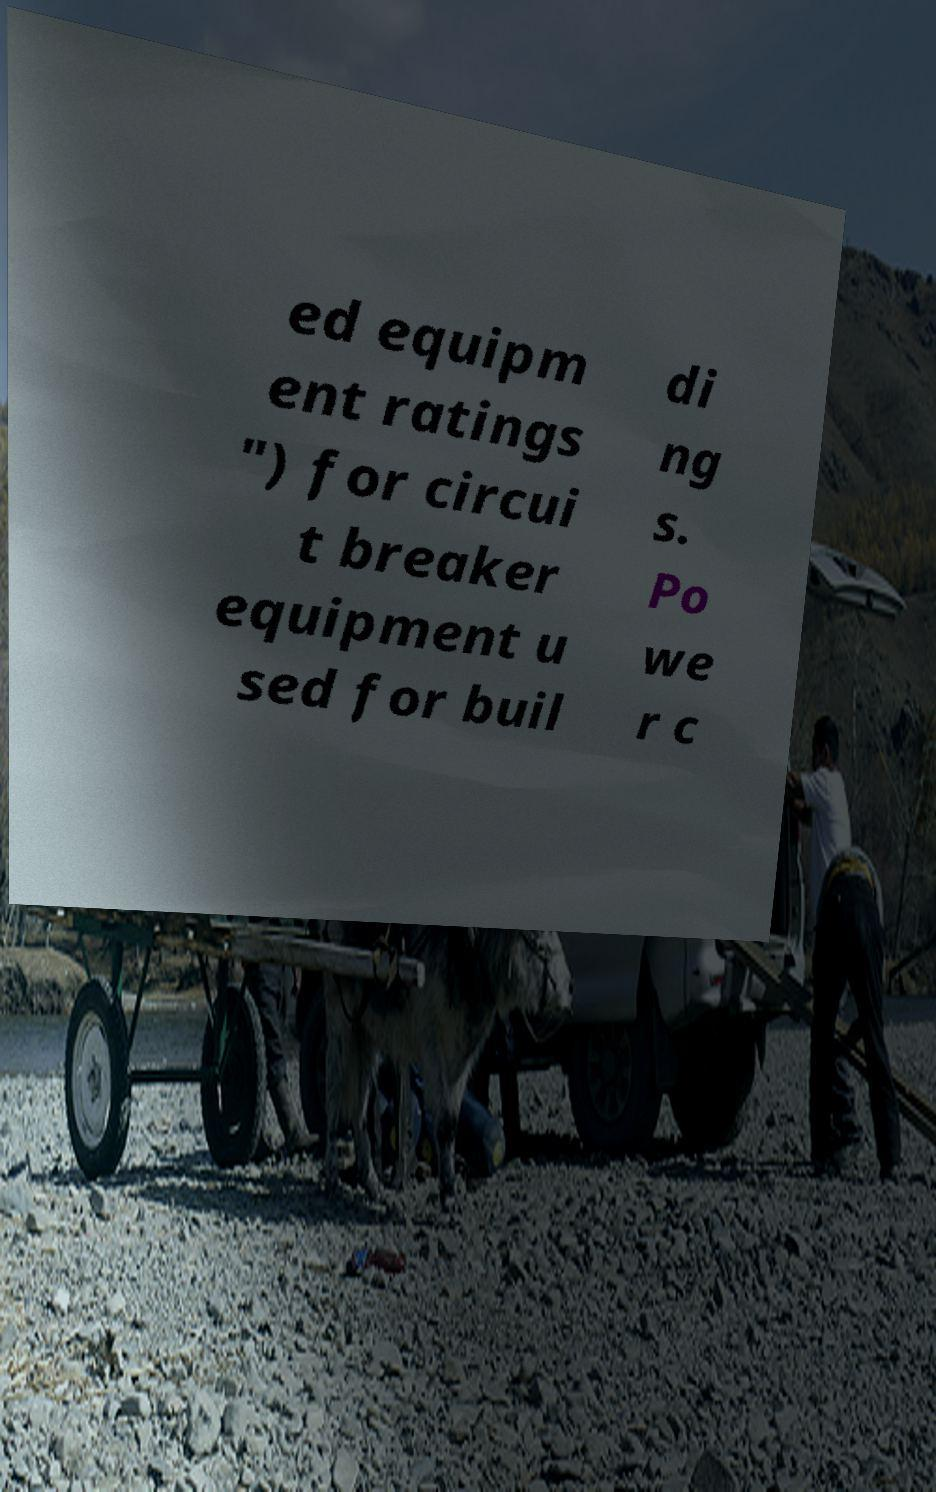Please read and relay the text visible in this image. What does it say? ed equipm ent ratings ") for circui t breaker equipment u sed for buil di ng s. Po we r c 